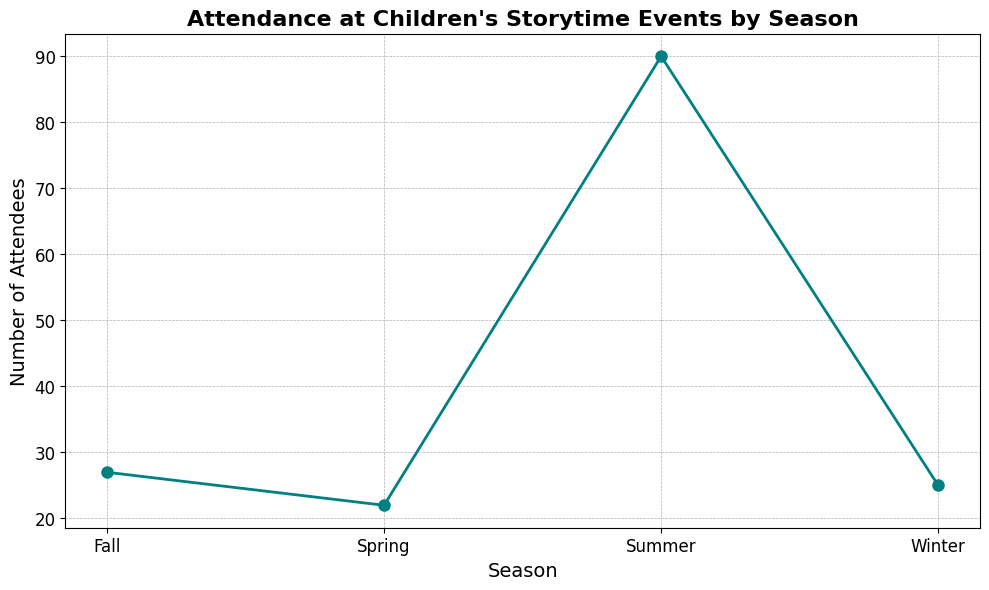What is the overall trend in attendance across seasons? By visually assessing the line, it shows an increase or decrease of attendance across the four seasons. The line fluctuates but shows a general inclination towards positive values after initial negatives.
Answer: Increasing with fluctuations Which season has the highest total number of attendees? By looking at the peak value on the line chart, the highest point corresponds to the ‘Summer’ season.
Answer: Summer Was there any season where attendance dropped below zero? The line chart shows values below zero, and these dips correspond to the 'Winter', 'Spring', and 'Fall' seasons.
Answer: Winter, Spring, Fall How does the attendance in Fall compare to Summer? The heights of the points indicate that Summer consistently has higher attendance compared to Fall.
Answer: Summer has higher attendance than Fall What is the difference in attendance between Spring and Winter in their last recorded points? By observing the final points of Spring (10) and Winter (20) on the chart and taking their difference, you get 10.
Answer: 10 Which season showed the most variability in attendance? By eyeing the highs and lows for each season's data points, the Spring season varies from -8 to 15 across its values, reflecting the most fluctuation.
Answer: Spring How does the line graph visually show the point with the biggest drop in attendance? The sharpest drop, visually, happens between Spring (15) and Spring (-8), noticeable as the steepest downward slope on the graph.
Answer: Between Spring (15) and Spring (-8) What is the sum of all the attendees in July? Adding the values of attendance in the Summer season (30, 25, 35) gives us the total sum, 90.
Answer: 90 In which season does the attendance start to improve after dipping into negative values? By following the line trend, the improvement starts after negative values in Winter; it improves in the following Winter session.
Answer: Winter Is the color of the line significant, and what impression does it give? The blue-green color of the line can symbolize calm and positive growth, adding to the interpretation of the attendance data.
Answer: Positive growth and calm interpretation 